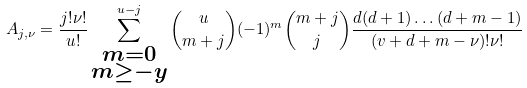<formula> <loc_0><loc_0><loc_500><loc_500>A _ { j , \nu } = \frac { j ! \nu ! } { u ! } \sum ^ { u - j } _ { \substack { m = 0 \\ m \geq - y } } { u \choose m + j } ( - 1 ) ^ { m } { m + j \choose j } \frac { d ( d + 1 ) \dots ( d + m - 1 ) } { ( v + d + m - \nu ) ! \nu ! }</formula> 